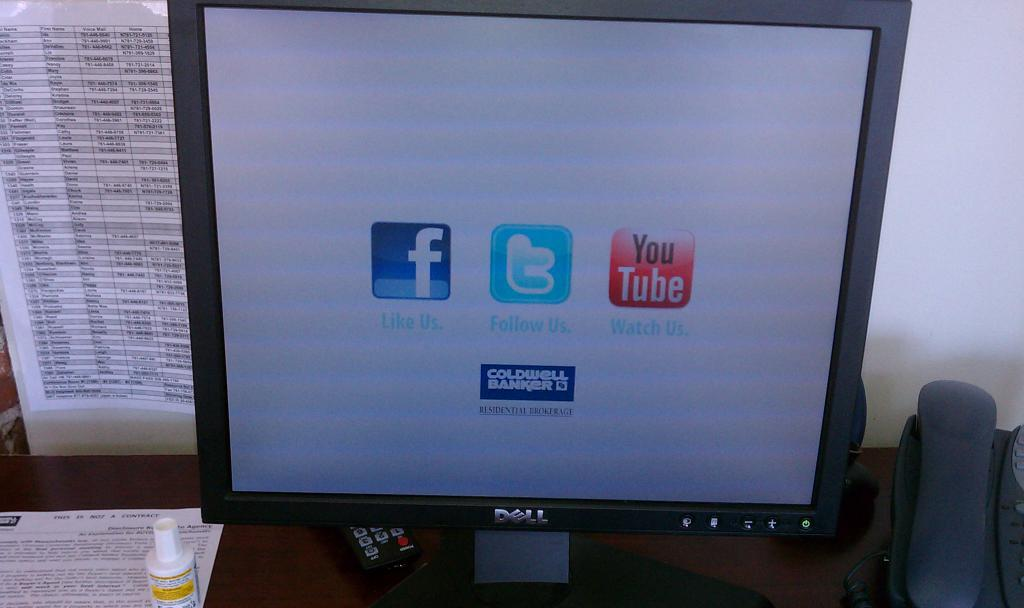<image>
Give a short and clear explanation of the subsequent image. a YouTube icon is on the screen of the monitor 